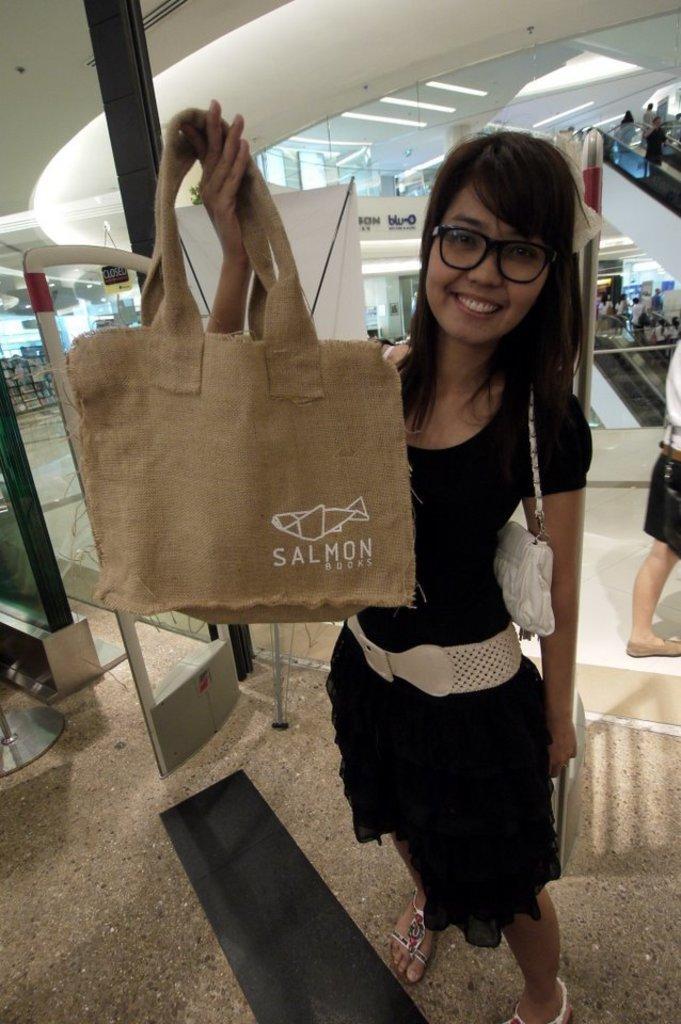Please provide a concise description of this image. In the image we can see there is a woman who is standing and holding a jute bag on which it's written "Salmon". 